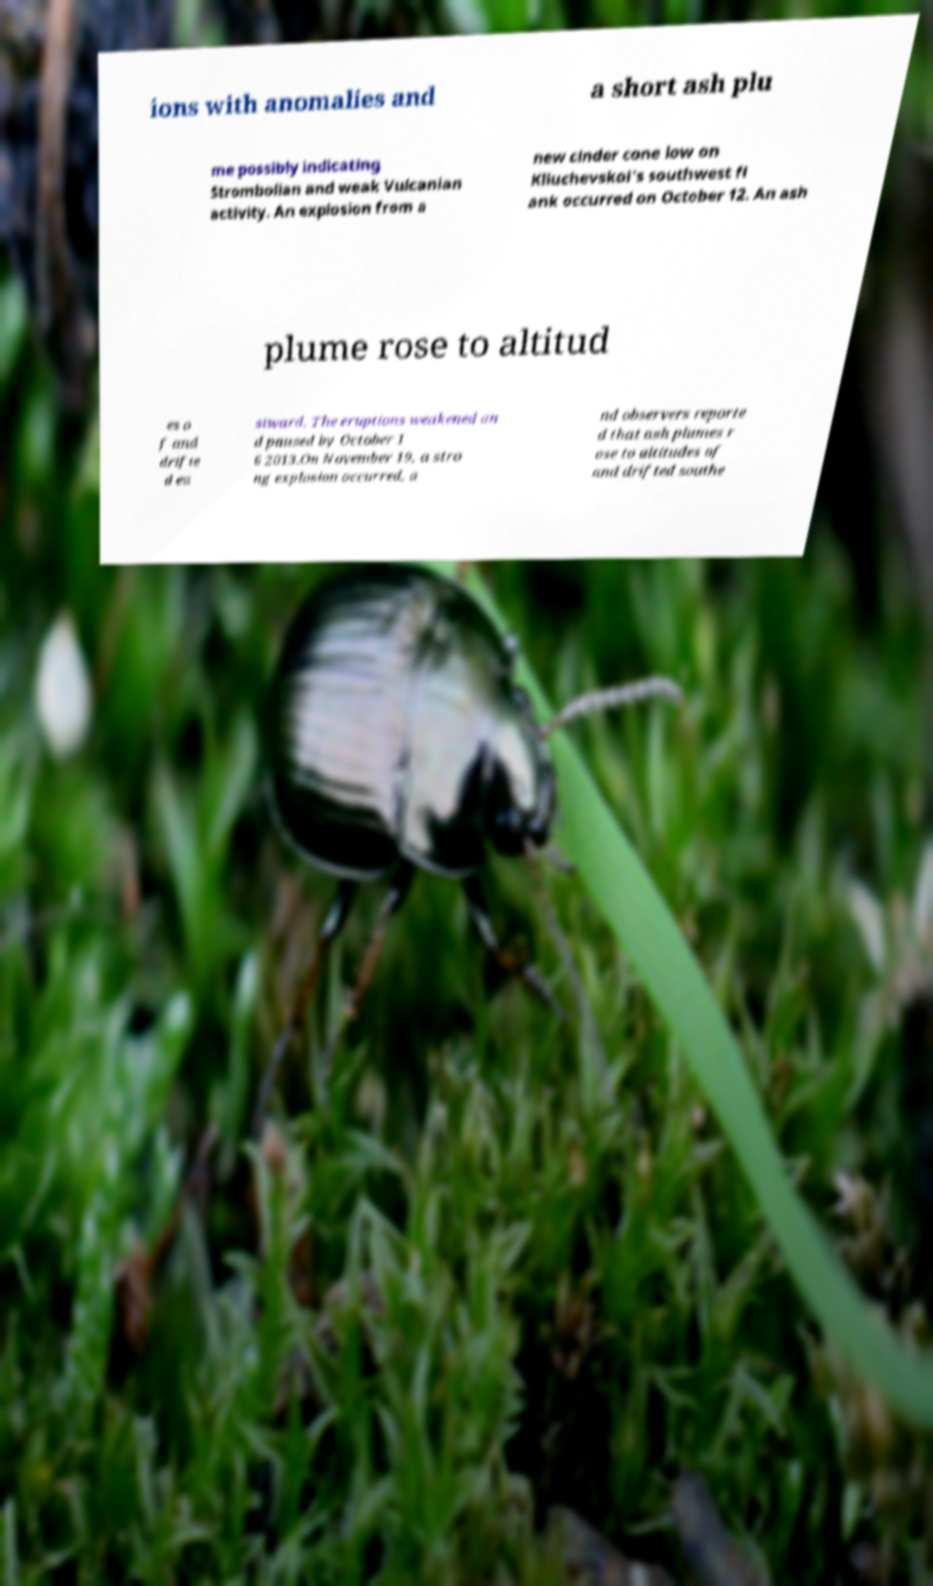There's text embedded in this image that I need extracted. Can you transcribe it verbatim? ions with anomalies and a short ash plu me possibly indicating Strombolian and weak Vulcanian activity. An explosion from a new cinder cone low on Kliuchevskoi's southwest fl ank occurred on October 12. An ash plume rose to altitud es o f and drifte d ea stward. The eruptions weakened an d paused by October 1 6 2013.On November 19, a stro ng explosion occurred, a nd observers reporte d that ash plumes r ose to altitudes of and drifted southe 